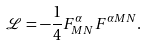<formula> <loc_0><loc_0><loc_500><loc_500>\mathcal { L } = - \frac { 1 } { 4 } F _ { M N } ^ { \alpha } F ^ { \alpha M N } .</formula> 